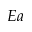<formula> <loc_0><loc_0><loc_500><loc_500>E a</formula> 